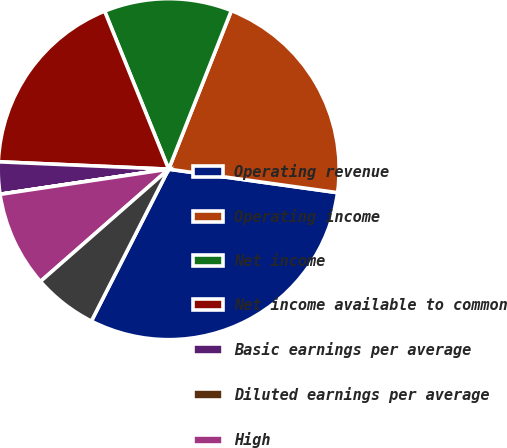Convert chart to OTSL. <chart><loc_0><loc_0><loc_500><loc_500><pie_chart><fcel>Operating revenue<fcel>Operating income<fcel>Net income<fcel>Net income available to common<fcel>Basic earnings per average<fcel>Diluted earnings per average<fcel>High<fcel>Low<nl><fcel>30.29%<fcel>21.21%<fcel>12.12%<fcel>18.18%<fcel>3.04%<fcel>0.01%<fcel>9.09%<fcel>6.06%<nl></chart> 